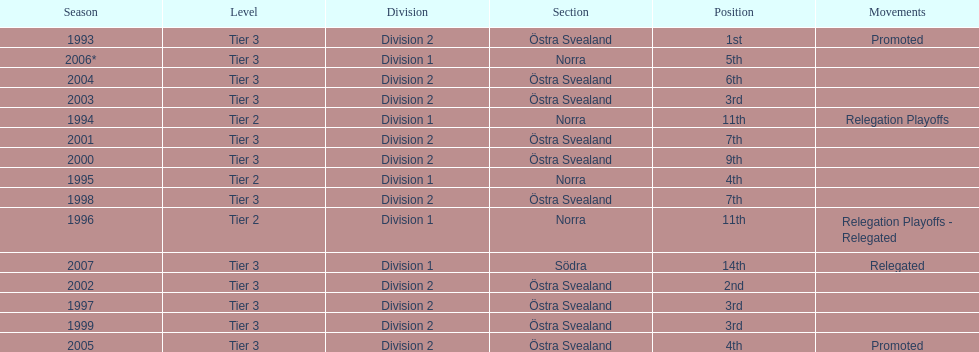When was the last time they accomplished a third-place standing before that? 1999. 